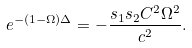Convert formula to latex. <formula><loc_0><loc_0><loc_500><loc_500>e ^ { - ( 1 - \Omega ) \Delta } = - \frac { s _ { 1 } s _ { 2 } C ^ { 2 } \Omega ^ { 2 } } { c ^ { 2 } } .</formula> 